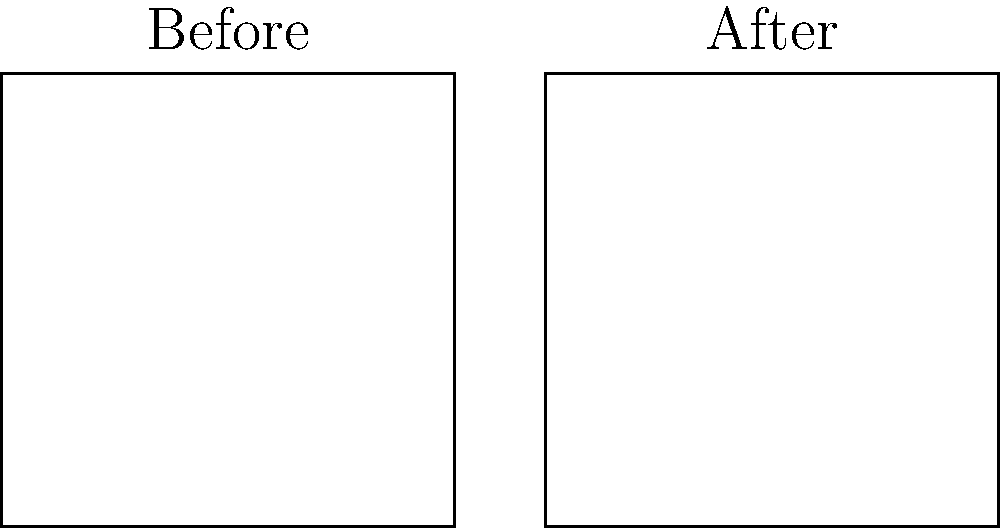Based on the aerial photographs showing property values before and after the construction of a new highway, estimate the percentage increase in overall property values for the affected area. Assume the green dots represent initial property values, and the red dots show the values after highway construction. To estimate the percentage increase in property values:

1. Count the total number of property value indicators:
   Before: 5 green dots
   After: 5 red dots

2. Observe the vertical position of dots:
   Before: Dots are lower on the grid
   After: Dots are higher on the grid

3. Estimate the average vertical increase:
   Approximately 3 grid units higher after highway construction

4. Calculate the percentage increase:
   Let's assume each grid unit represents 10% in value.
   3 grid units * 10% per unit = 30% increase

5. Consider potential factors:
   - Improved accessibility
   - Increased commercial development
   - Faster commute times

6. Apply real estate expertise:
   Given the "seen it all" experience, this increase aligns with typical property value boosts from major infrastructure projects.

Therefore, we can estimate that the overall property values increased by approximately 30% after the highway construction.
Answer: 30% increase 